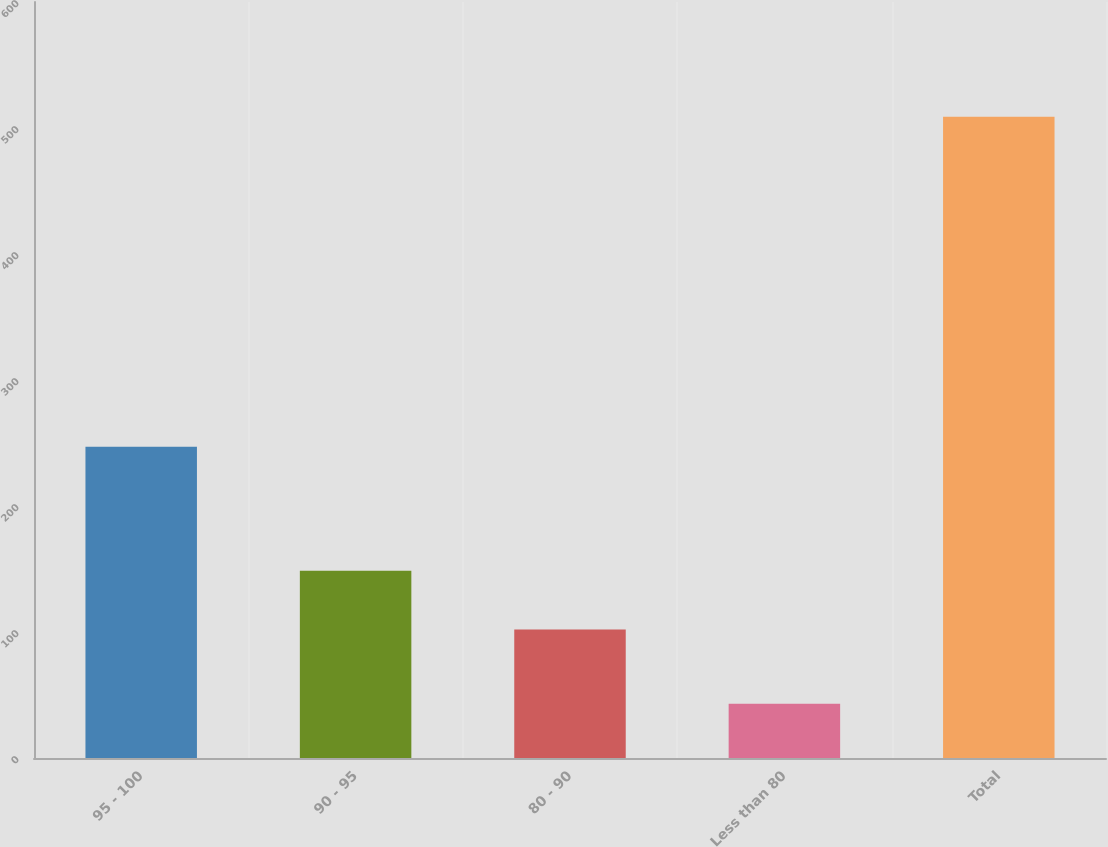<chart> <loc_0><loc_0><loc_500><loc_500><bar_chart><fcel>95 - 100<fcel>90 - 95<fcel>80 - 90<fcel>Less than 80<fcel>Total<nl><fcel>247<fcel>148.6<fcel>102<fcel>43<fcel>509<nl></chart> 